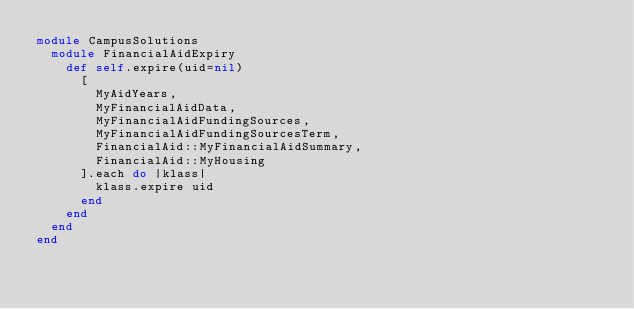Convert code to text. <code><loc_0><loc_0><loc_500><loc_500><_Ruby_>module CampusSolutions
  module FinancialAidExpiry
    def self.expire(uid=nil)
      [
        MyAidYears,
        MyFinancialAidData,
        MyFinancialAidFundingSources,
        MyFinancialAidFundingSourcesTerm,
        FinancialAid::MyFinancialAidSummary,
        FinancialAid::MyHousing
      ].each do |klass|
        klass.expire uid
      end
    end
  end
end
</code> 